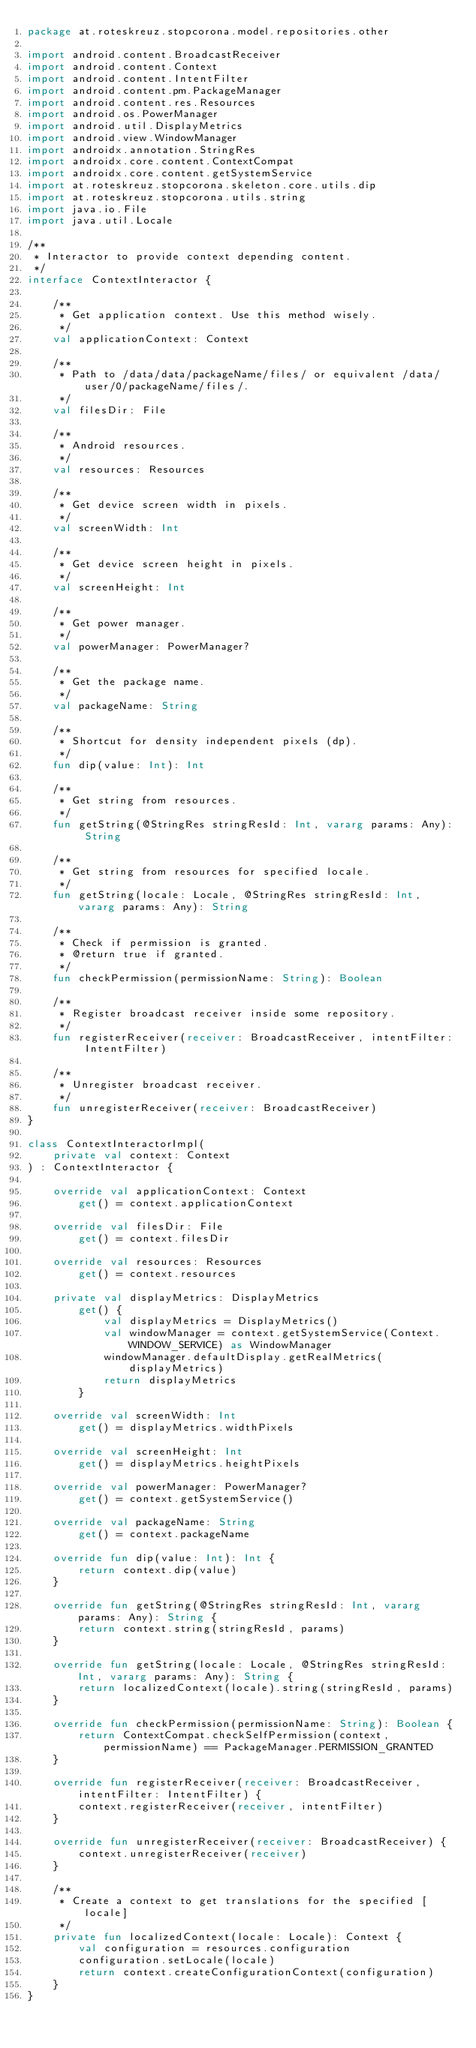<code> <loc_0><loc_0><loc_500><loc_500><_Kotlin_>package at.roteskreuz.stopcorona.model.repositories.other

import android.content.BroadcastReceiver
import android.content.Context
import android.content.IntentFilter
import android.content.pm.PackageManager
import android.content.res.Resources
import android.os.PowerManager
import android.util.DisplayMetrics
import android.view.WindowManager
import androidx.annotation.StringRes
import androidx.core.content.ContextCompat
import androidx.core.content.getSystemService
import at.roteskreuz.stopcorona.skeleton.core.utils.dip
import at.roteskreuz.stopcorona.utils.string
import java.io.File
import java.util.Locale

/**
 * Interactor to provide context depending content.
 */
interface ContextInteractor {

    /**
     * Get application context. Use this method wisely.
     */
    val applicationContext: Context

    /**
     * Path to /data/data/packageName/files/ or equivalent /data/user/0/packageName/files/.
     */
    val filesDir: File

    /**
     * Android resources.
     */
    val resources: Resources

    /**
     * Get device screen width in pixels.
     */
    val screenWidth: Int

    /**
     * Get device screen height in pixels.
     */
    val screenHeight: Int

    /**
     * Get power manager.
     */
    val powerManager: PowerManager?

    /**
     * Get the package name.
     */
    val packageName: String

    /**
     * Shortcut for density independent pixels (dp).
     */
    fun dip(value: Int): Int

    /**
     * Get string from resources.
     */
    fun getString(@StringRes stringResId: Int, vararg params: Any): String

    /**
     * Get string from resources for specified locale.
     */
    fun getString(locale: Locale, @StringRes stringResId: Int, vararg params: Any): String

    /**
     * Check if permission is granted.
     * @return true if granted.
     */
    fun checkPermission(permissionName: String): Boolean

    /**
     * Register broadcast receiver inside some repository.
     */
    fun registerReceiver(receiver: BroadcastReceiver, intentFilter: IntentFilter)

    /**
     * Unregister broadcast receiver.
     */
    fun unregisterReceiver(receiver: BroadcastReceiver)
}

class ContextInteractorImpl(
    private val context: Context
) : ContextInteractor {

    override val applicationContext: Context
        get() = context.applicationContext

    override val filesDir: File
        get() = context.filesDir

    override val resources: Resources
        get() = context.resources

    private val displayMetrics: DisplayMetrics
        get() {
            val displayMetrics = DisplayMetrics()
            val windowManager = context.getSystemService(Context.WINDOW_SERVICE) as WindowManager
            windowManager.defaultDisplay.getRealMetrics(displayMetrics)
            return displayMetrics
        }

    override val screenWidth: Int
        get() = displayMetrics.widthPixels

    override val screenHeight: Int
        get() = displayMetrics.heightPixels

    override val powerManager: PowerManager?
        get() = context.getSystemService()

    override val packageName: String
        get() = context.packageName

    override fun dip(value: Int): Int {
        return context.dip(value)
    }

    override fun getString(@StringRes stringResId: Int, vararg params: Any): String {
        return context.string(stringResId, params)
    }

    override fun getString(locale: Locale, @StringRes stringResId: Int, vararg params: Any): String {
        return localizedContext(locale).string(stringResId, params)
    }

    override fun checkPermission(permissionName: String): Boolean {
        return ContextCompat.checkSelfPermission(context, permissionName) == PackageManager.PERMISSION_GRANTED
    }

    override fun registerReceiver(receiver: BroadcastReceiver, intentFilter: IntentFilter) {
        context.registerReceiver(receiver, intentFilter)
    }

    override fun unregisterReceiver(receiver: BroadcastReceiver) {
        context.unregisterReceiver(receiver)
    }

    /**
     * Create a context to get translations for the specified [locale]
     */
    private fun localizedContext(locale: Locale): Context {
        val configuration = resources.configuration
        configuration.setLocale(locale)
        return context.createConfigurationContext(configuration)
    }
}</code> 